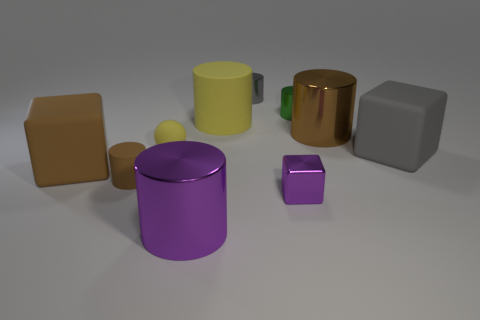Are the tiny purple block and the block left of the tiny yellow ball made of the same material?
Provide a succinct answer. No. There is a object that is the same color as the small sphere; what is its size?
Give a very brief answer. Large. Is there a large gray cube made of the same material as the small block?
Your answer should be compact. No. How many objects are either metallic cylinders that are in front of the small yellow matte thing or metallic things that are on the left side of the tiny green object?
Your answer should be very brief. 3. Do the gray rubber object and the small object behind the tiny green shiny cylinder have the same shape?
Your response must be concise. No. How many other objects are the same shape as the tiny green object?
Your response must be concise. 5. What number of things are small yellow spheres or gray cylinders?
Give a very brief answer. 2. Do the tiny cube and the tiny matte sphere have the same color?
Your response must be concise. No. Are there any other things that are the same size as the gray cylinder?
Your answer should be compact. Yes. There is a yellow object that is on the left side of the large metallic cylinder left of the green shiny thing; what is its shape?
Provide a succinct answer. Sphere. 